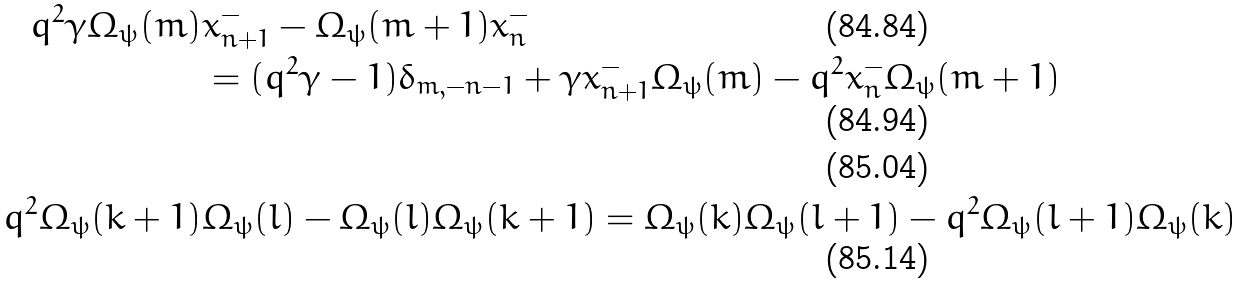<formula> <loc_0><loc_0><loc_500><loc_500>q ^ { 2 } \gamma \Omega _ { \psi } ( m ) & x ^ { - } _ { n + 1 } - \Omega _ { \psi } ( m + 1 ) x ^ { - } _ { n } \\ & = ( q ^ { 2 } \gamma - 1 ) \delta _ { m , - n - 1 } + \gamma x ^ { - } _ { n + 1 } \Omega _ { \psi } ( m ) - q ^ { 2 } x ^ { - } _ { n } \Omega _ { \psi } ( m + 1 ) \\ \\ q ^ { 2 } \Omega _ { \psi } ( k + 1 ) & \Omega _ { \psi } ( l ) - \Omega _ { \psi } ( l ) \Omega _ { \psi } ( k + 1 ) = \Omega _ { \psi } ( k ) \Omega _ { \psi } ( l + 1 ) - q ^ { 2 } \Omega _ { \psi } ( l + 1 ) \Omega _ { \psi } ( k )</formula> 